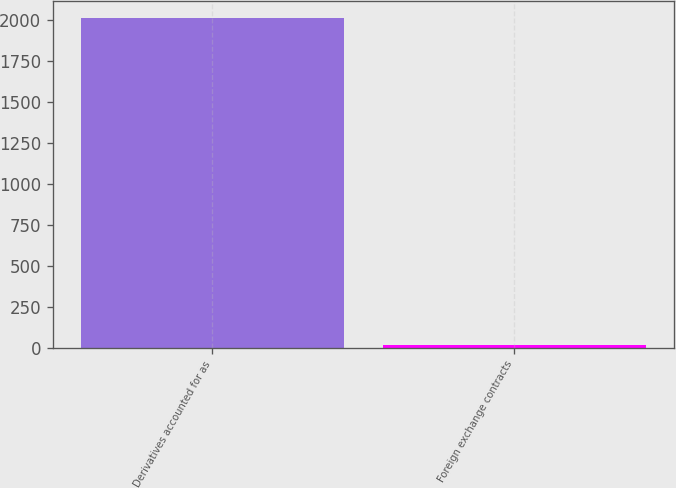<chart> <loc_0><loc_0><loc_500><loc_500><bar_chart><fcel>Derivatives accounted for as<fcel>Foreign exchange contracts<nl><fcel>2014<fcel>14<nl></chart> 